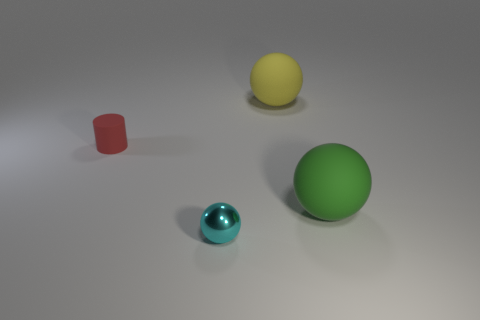Are any large cylinders visible?
Keep it short and to the point. No. What number of other objects are there of the same size as the metallic object?
Provide a succinct answer. 1. Does the cyan sphere have the same material as the tiny thing that is to the left of the cyan ball?
Provide a short and direct response. No. Are there the same number of green balls that are to the right of the cyan ball and yellow rubber objects that are in front of the yellow rubber sphere?
Ensure brevity in your answer.  No. What material is the large yellow ball?
Provide a succinct answer. Rubber. There is a cylinder that is the same size as the cyan sphere; what is its color?
Your answer should be compact. Red. There is a big matte ball to the left of the big green rubber object; is there a red rubber cylinder that is right of it?
Your response must be concise. No. How many cubes are green matte objects or matte objects?
Provide a succinct answer. 0. What is the size of the ball that is on the left side of the big sphere behind the rubber ball in front of the big yellow ball?
Provide a short and direct response. Small. There is a red matte thing; are there any yellow objects in front of it?
Your answer should be very brief. No. 